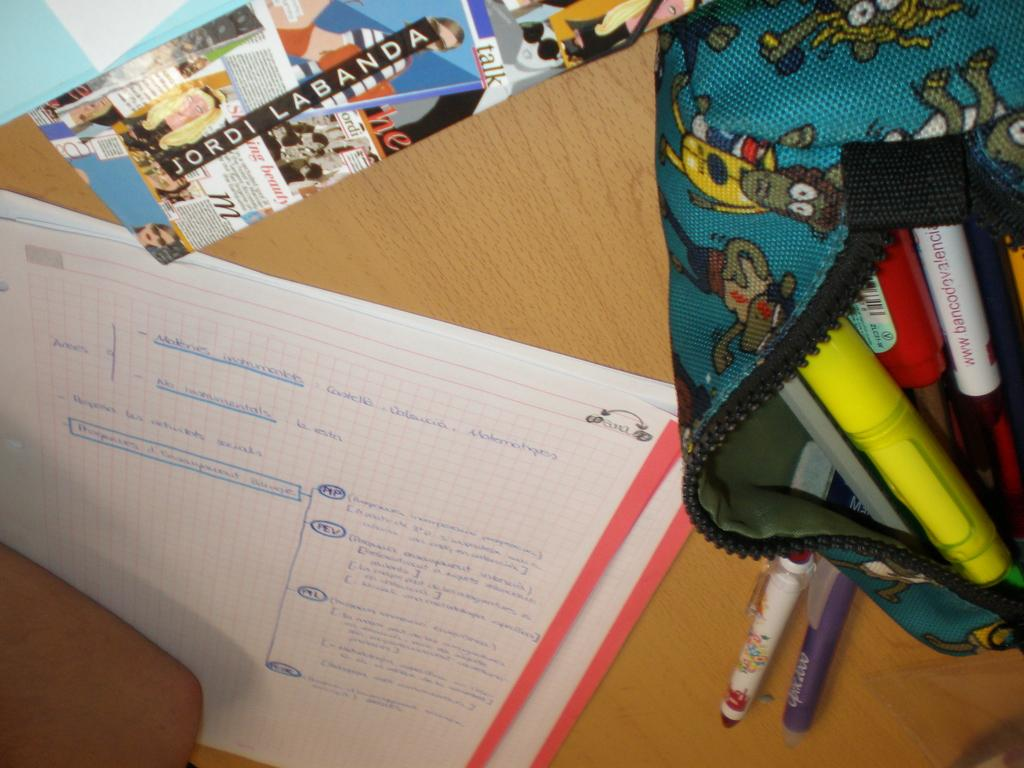Provide a one-sentence caption for the provided image. A desk with a sticker that says Jordi Labanda has an open purse with markers in it. 